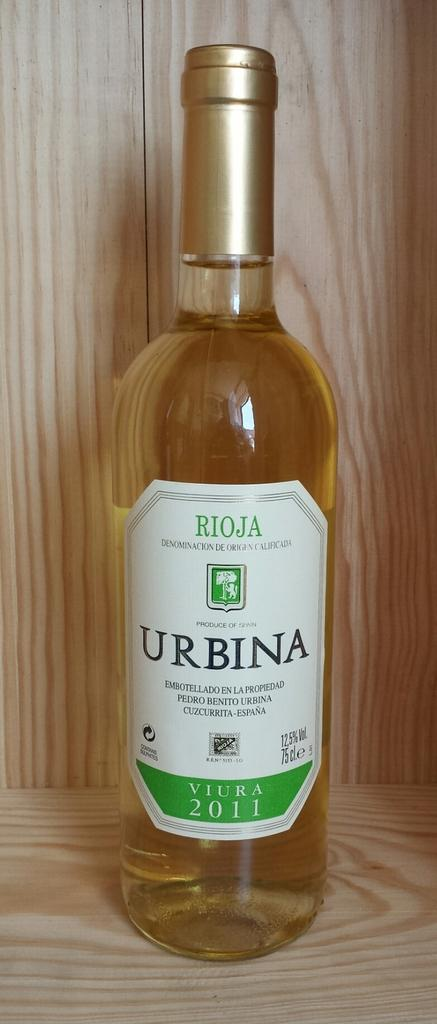Provide a one-sentence caption for the provided image. An amber color of Urbina wine from 2011 being displayed on a shelf. 